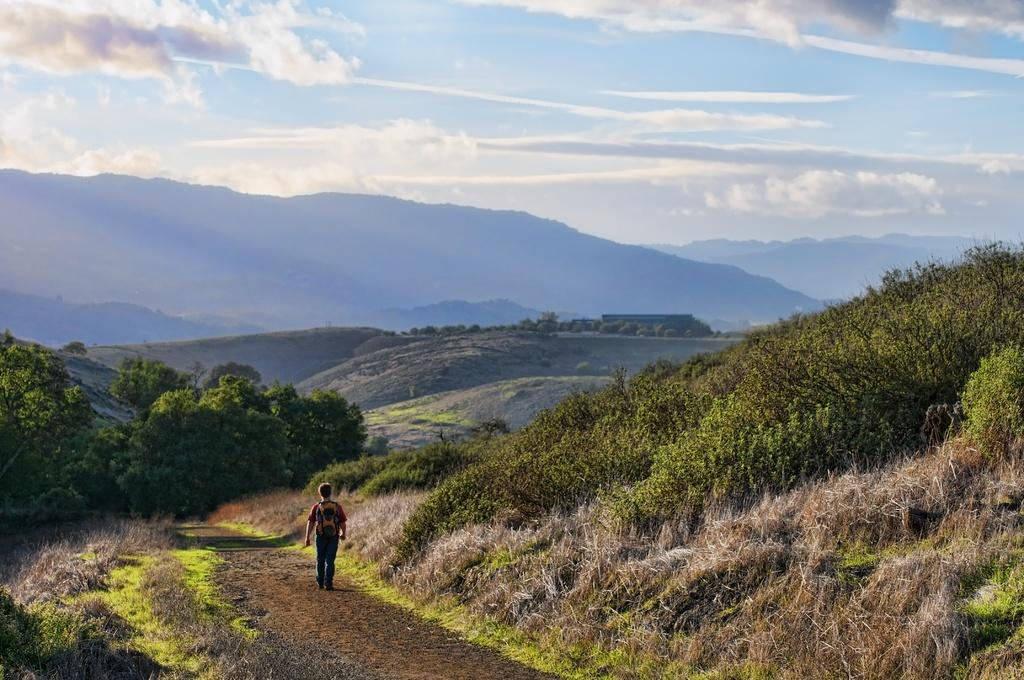What is the main subject of the image? There is a man in the image. What is the man doing in the image? The man is carrying a bag and walking on a path. What can be seen in the background of the image? There are trees, mountains, and the sky visible in the background of the image. What is the condition of the sky in the image? The sky is visible in the background of the image, and clouds are present. What type of sound can be heard coming from the man in the image? There is no sound present in the image, so it is not possible to determine what, if any, sound might be heard. 